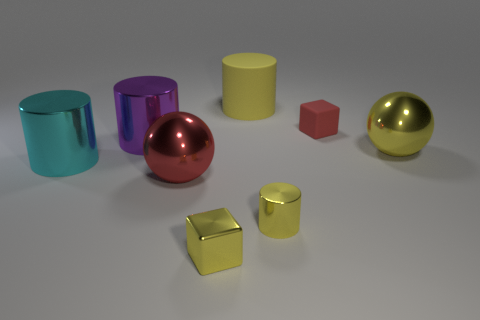The big metallic thing that is right of the shiny sphere that is in front of the cyan shiny thing is what shape?
Make the answer very short. Sphere. The red thing behind the metal cylinder behind the ball that is behind the cyan metallic thing is made of what material?
Offer a very short reply. Rubber. Are there any yellow cubes that have the same size as the cyan shiny thing?
Provide a short and direct response. No. What color is the big sphere to the right of the red thing that is in front of the purple shiny cylinder?
Keep it short and to the point. Yellow. How many yellow shiny cylinders are there?
Keep it short and to the point. 1. Does the metal block have the same color as the matte block?
Offer a terse response. No. Is the number of big shiny things that are in front of the cyan shiny thing less than the number of cylinders that are to the right of the small metallic cylinder?
Keep it short and to the point. No. What is the color of the small rubber thing?
Your response must be concise. Red. How many large matte cylinders have the same color as the tiny matte thing?
Offer a terse response. 0. There is a red block; are there any balls to the right of it?
Your response must be concise. Yes. 